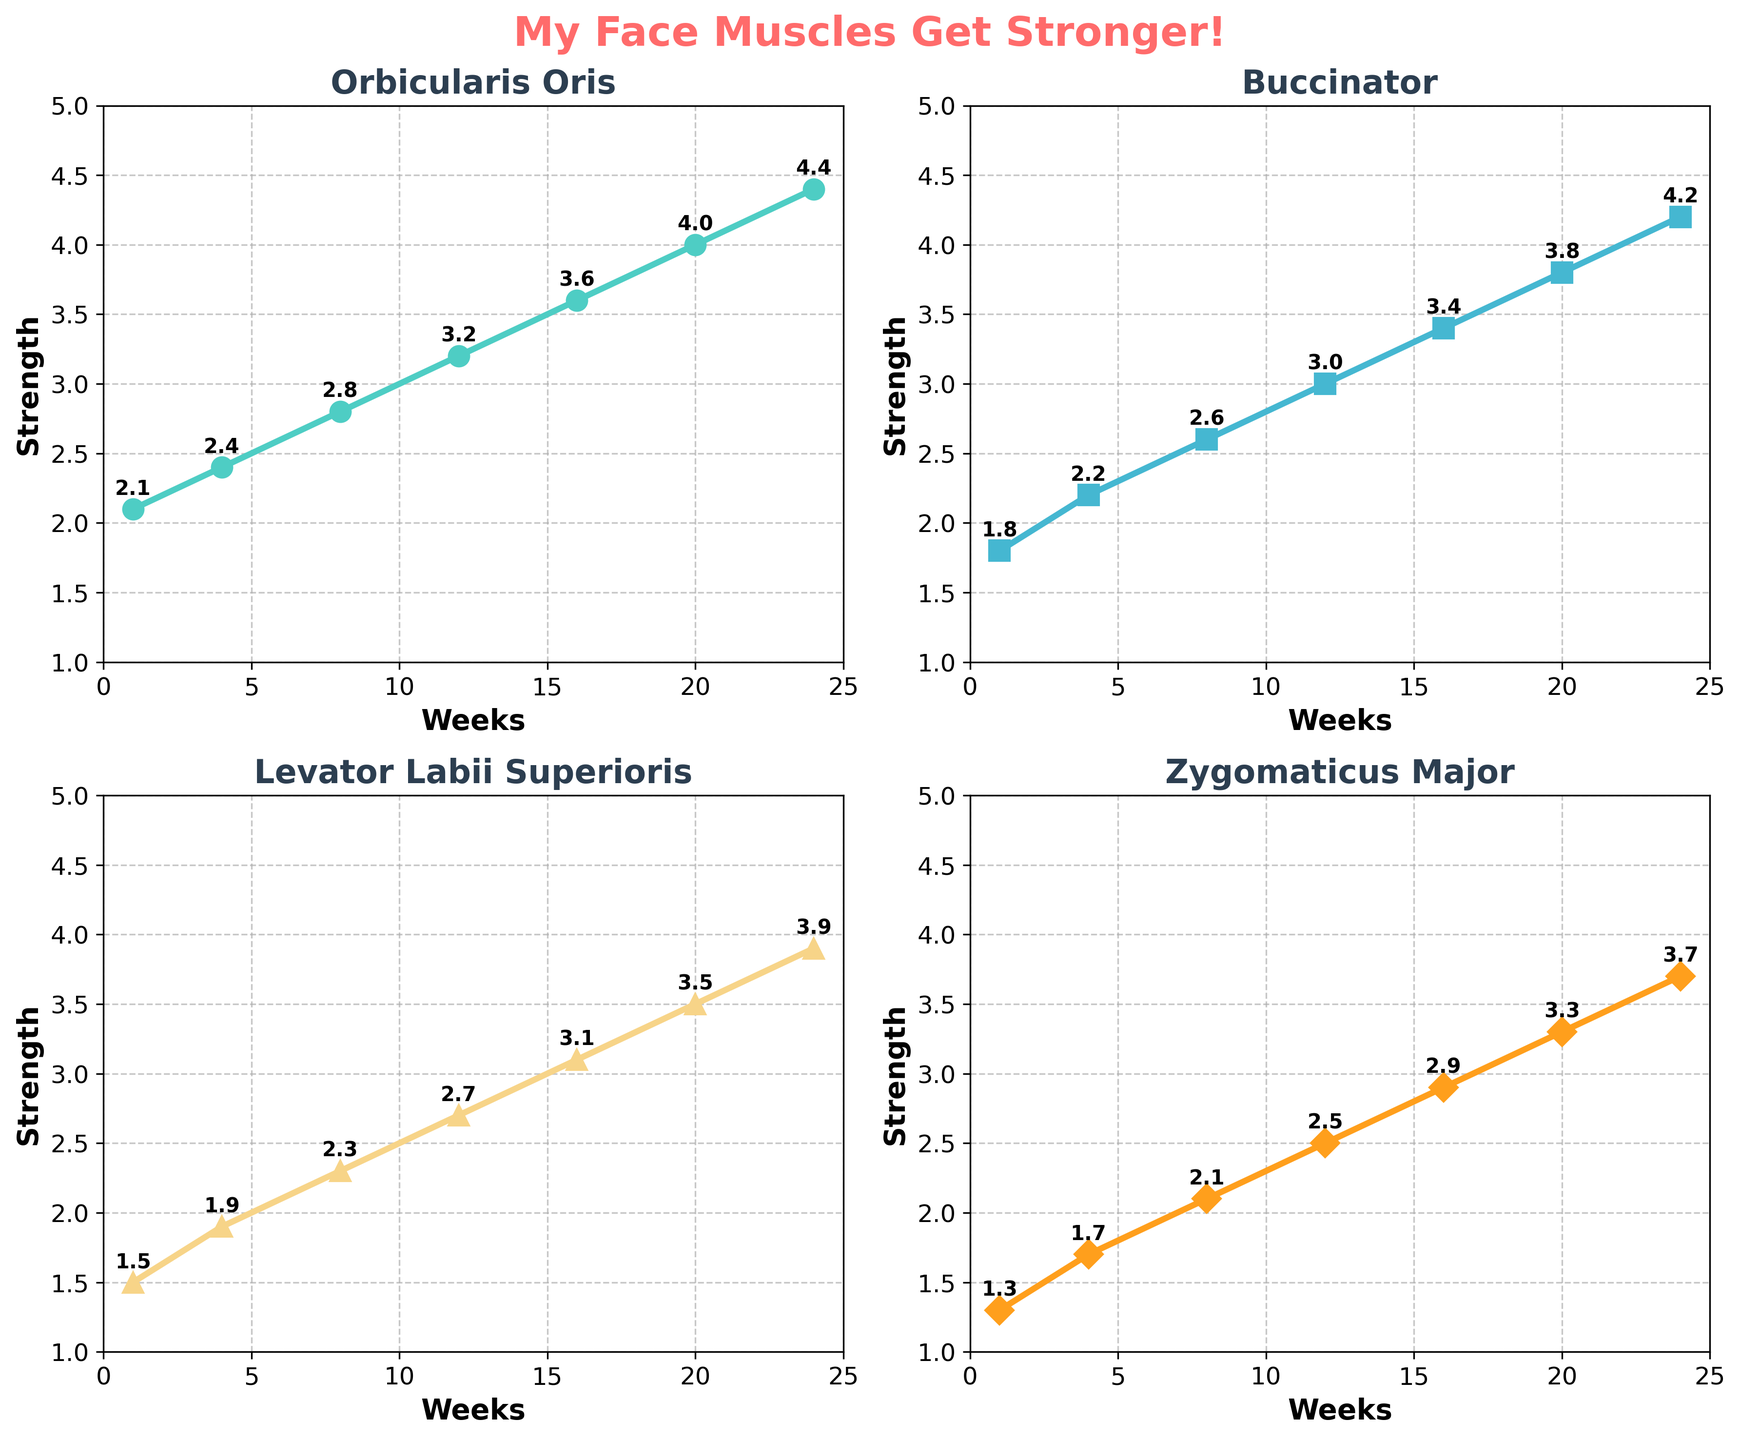What's the title of the figure? Look at the top center of the figure to find the title. It's displayed in bold text and larger font.
Answer: My Face Muscles Get Stronger! Are there more than one plot in the figure? Observe the layout of the figure. There are multiple smaller plots within the big figure.
Answer: Yes What color is used for the Orbicularis Oris muscle plot? Check the line color in the subplot titled "Orbicularis Oris". The color is a prominent visual element.
Answer: Light green How many weeks' data are shown in each subplot? Look at the x-axis (Weeks) and count the number of distinct points plotted on the graphs.
Answer: 7 Which muscle shows the maximum strength improvement by week 24? Compare the data points at week 24 for each muscle in their respective subplots to see which one has the highest value.
Answer: Orbicularis Oris Which muscle has the least strength at the beginning (week 1)? Look at the data points at week 1 across all subplots and identify the smallest value.
Answer: Zygomaticus Major By how much did the strength of the Levator Labii Superioris increase from week 1 to week 4? Locate the strength values for the Levator Labii Superioris at week 1 and week 4, then subtract the week 1 value from the week 4 value (1.9 - 1.5).
Answer: 0.4 Comparing week 8, which muscle is stronger, Buccinator or Levator Labii Superioris and by how much? Look at the data points for week 8 in the Buccinator and Levator Labii Superioris subplots. Compare their values and find the difference (2.6 - 2.3).
Answer: Buccinator by 0.3 Which muscle's strength has the smoothest and most consistent increase over time? Analyze the lines on each subplot. The smoothest and most consistent line will have fewer abrupt changes and will steadily increase.
Answer: Orbicularis Oris 